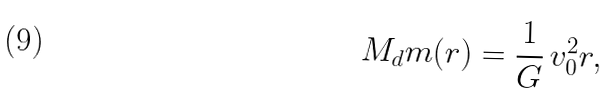<formula> <loc_0><loc_0><loc_500><loc_500>M _ { d } m ( r ) = \frac { 1 } { G } \, v _ { 0 } ^ { 2 } r ,</formula> 